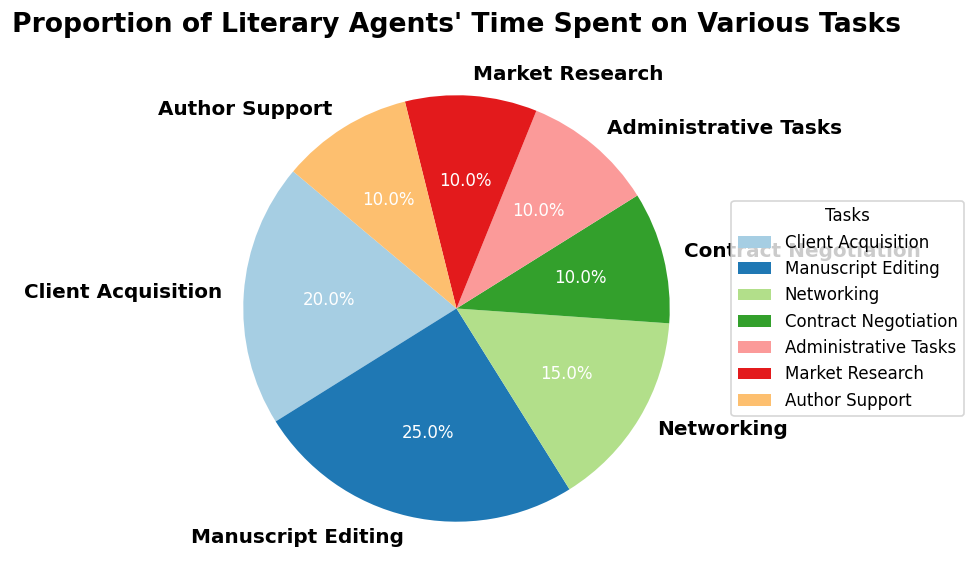How much time is collectively spent on Networking, Market Research, and Author Support? To calculate the combined time spent on Networking, Market Research, and Author Support, add the percentages allocated to these tasks: 15% (Networking) + 10% (Market Research) + 10% (Author Support) = 35%.
Answer: 35% Which task takes up the largest proportion of time for literary agents? The task with the largest proportion of time is the segment with the highest percentage. From the pie chart, Manuscript Editing has the highest percentage at 25%.
Answer: Manuscript Editing Compare the time spent on Client Acquisition to Administrative Tasks. Client Acquisition accounts for 20%, while Administrative Tasks account for 10%. The proportion of time spent on Client Acquisition is twice that spent on Administrative Tasks.
Answer: Client Acquisition is twice that of Administrative Tasks What is the proportion of time spent on tasks that are not directly related to client interaction (i.e., excluding Client Acquisition and Author Support)? Sum the percentages of tasks not directly related to client interaction: Manuscript Editing (25%), Networking (15%), Contract Negotiation (10%), Administrative Tasks (10%), and Market Research (10%). 25% + 15% + 10% + 10% + 10% = 70%.
Answer: 70% How much more time is spent on Manuscript Editing compared to Contract Negotiation? Manuscript Editing is 25%, and Contract Negotiation is 10%. The difference is 25% - 10% = 15%.
Answer: 15% Identify the tasks that each account for 10% of the literary agent's time. From the pie chart, Contract Negotiation, Administrative Tasks, Market Research, and Author Support each account for 10%.
Answer: Contract Negotiation, Administrative Tasks, Market Research, Author Support 